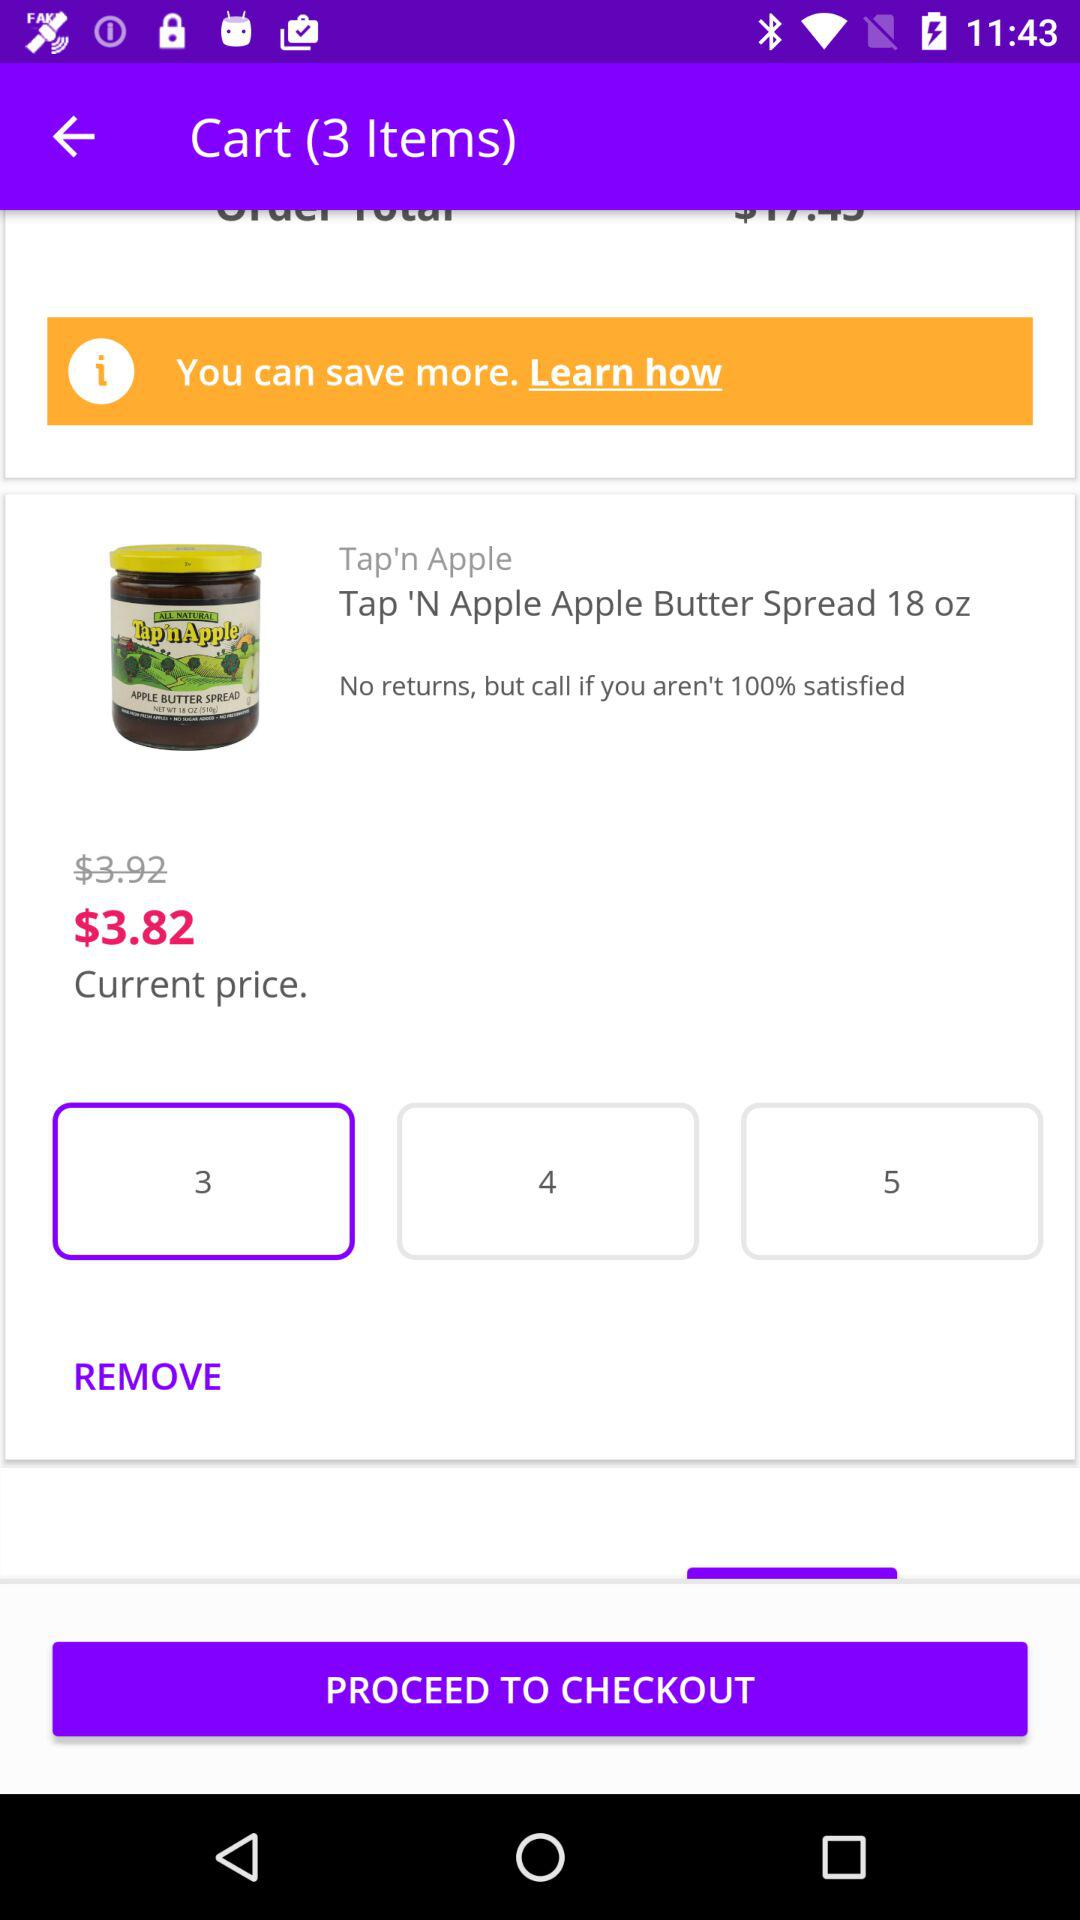What is the current price? The current price is $3.82. 